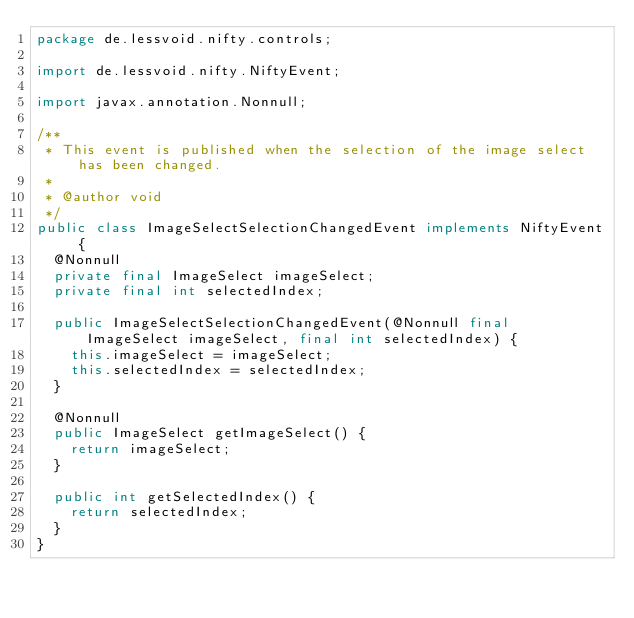Convert code to text. <code><loc_0><loc_0><loc_500><loc_500><_Java_>package de.lessvoid.nifty.controls;

import de.lessvoid.nifty.NiftyEvent;

import javax.annotation.Nonnull;

/**
 * This event is published when the selection of the image select has been changed.
 *
 * @author void
 */
public class ImageSelectSelectionChangedEvent implements NiftyEvent {
  @Nonnull
  private final ImageSelect imageSelect;
  private final int selectedIndex;

  public ImageSelectSelectionChangedEvent(@Nonnull final ImageSelect imageSelect, final int selectedIndex) {
    this.imageSelect = imageSelect;
    this.selectedIndex = selectedIndex;
  }

  @Nonnull
  public ImageSelect getImageSelect() {
    return imageSelect;
  }

  public int getSelectedIndex() {
    return selectedIndex;
  }
}
</code> 